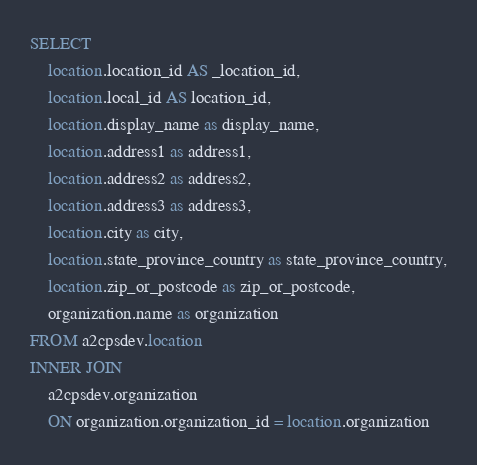<code> <loc_0><loc_0><loc_500><loc_500><_SQL_>SELECT
    location.location_id AS _location_id,
    location.local_id AS location_id,
    location.display_name as display_name,
    location.address1 as address1,
    location.address2 as address2,
    location.address3 as address3,
    location.city as city,
    location.state_province_country as state_province_country,
    location.zip_or_postcode as zip_or_postcode,
    organization.name as organization
FROM a2cpsdev.location
INNER JOIN
    a2cpsdev.organization
    ON organization.organization_id = location.organization
</code> 